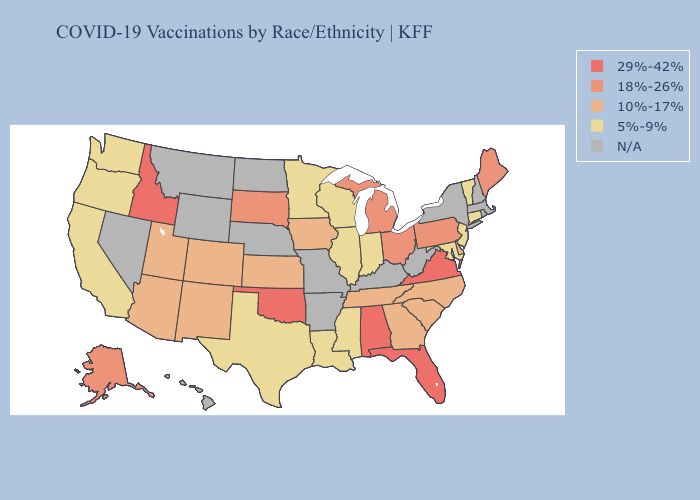What is the highest value in states that border Louisiana?
Concise answer only. 5%-9%. Name the states that have a value in the range 10%-17%?
Write a very short answer. Arizona, Colorado, Delaware, Georgia, Iowa, Kansas, New Mexico, North Carolina, South Carolina, Tennessee, Utah. Does the map have missing data?
Keep it brief. Yes. Among the states that border Indiana , which have the highest value?
Concise answer only. Michigan, Ohio. Name the states that have a value in the range N/A?
Short answer required. Arkansas, Hawaii, Kentucky, Massachusetts, Missouri, Montana, Nebraska, Nevada, New Hampshire, New York, North Dakota, Rhode Island, West Virginia, Wyoming. What is the lowest value in the South?
Write a very short answer. 5%-9%. What is the value of Delaware?
Answer briefly. 10%-17%. Does the first symbol in the legend represent the smallest category?
Short answer required. No. What is the value of Iowa?
Concise answer only. 10%-17%. What is the value of Hawaii?
Quick response, please. N/A. Name the states that have a value in the range 10%-17%?
Answer briefly. Arizona, Colorado, Delaware, Georgia, Iowa, Kansas, New Mexico, North Carolina, South Carolina, Tennessee, Utah. What is the value of Wyoming?
Write a very short answer. N/A. Name the states that have a value in the range 10%-17%?
Short answer required. Arizona, Colorado, Delaware, Georgia, Iowa, Kansas, New Mexico, North Carolina, South Carolina, Tennessee, Utah. 